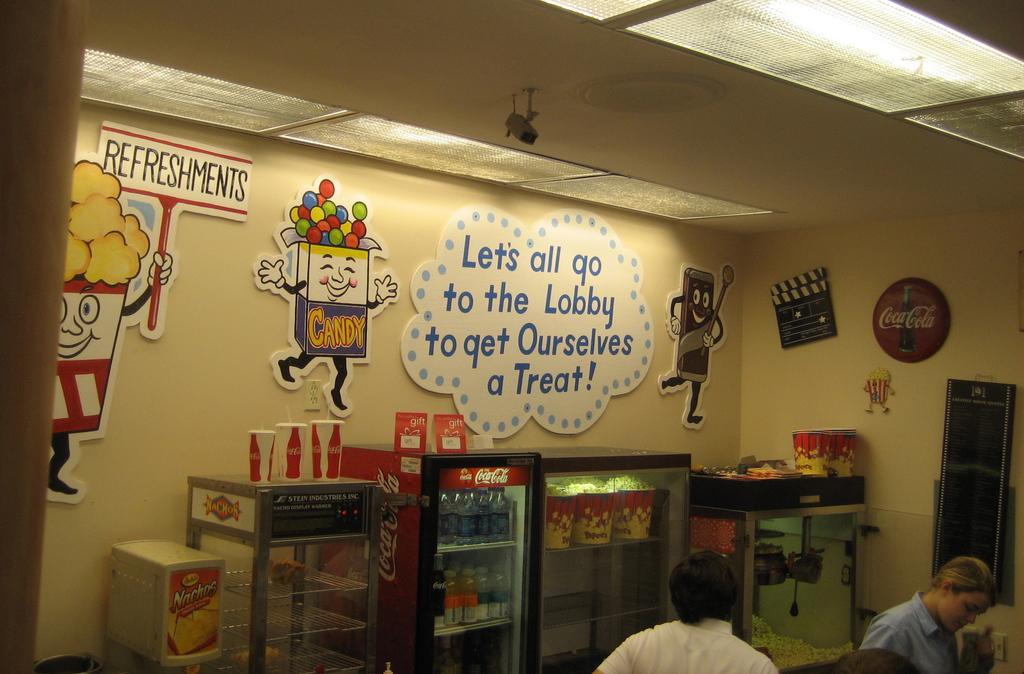In one or two sentences, can you explain what this image depicts? In this image we can see some boards and stickers on a wall with some text text on them. We can also see some containers containing some bottles and some food inside them and a machine. On the bottom of the image we can see some people. On the top of the image we can see some ceiling lights to a roof. 